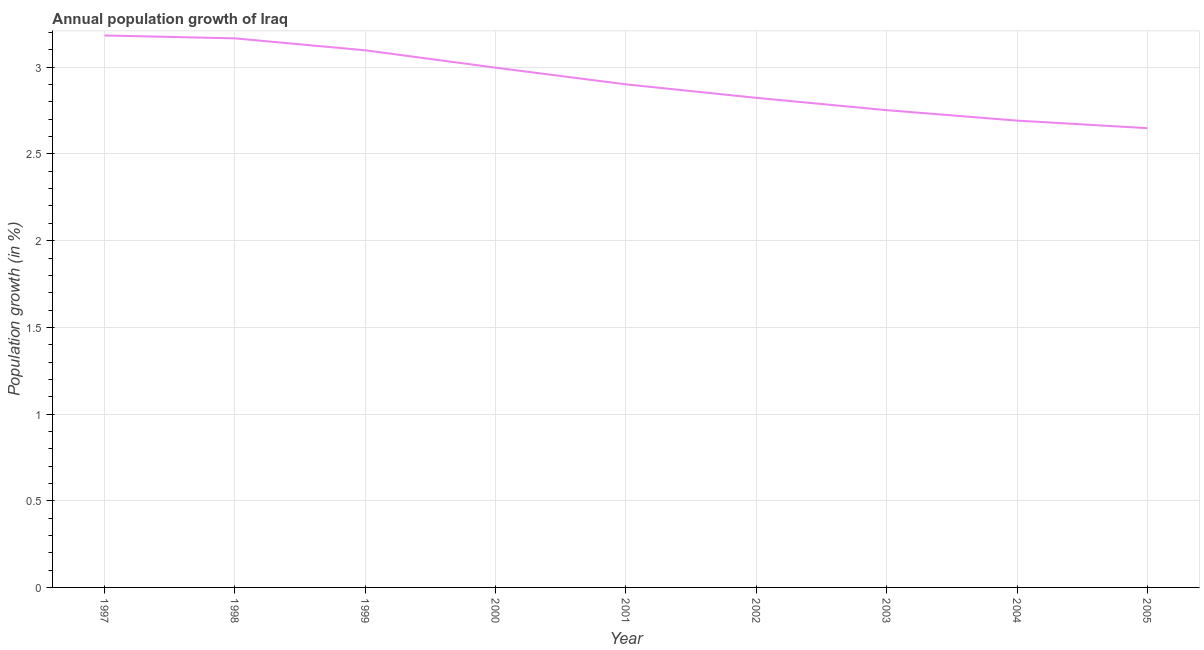What is the population growth in 2002?
Provide a short and direct response. 2.82. Across all years, what is the maximum population growth?
Make the answer very short. 3.18. Across all years, what is the minimum population growth?
Provide a succinct answer. 2.65. In which year was the population growth maximum?
Ensure brevity in your answer.  1997. In which year was the population growth minimum?
Provide a succinct answer. 2005. What is the sum of the population growth?
Offer a very short reply. 26.27. What is the difference between the population growth in 1999 and 2002?
Your answer should be compact. 0.27. What is the average population growth per year?
Give a very brief answer. 2.92. What is the median population growth?
Make the answer very short. 2.9. In how many years, is the population growth greater than 2.7 %?
Your answer should be very brief. 7. Do a majority of the years between 2004 and 2002 (inclusive) have population growth greater than 0.8 %?
Offer a terse response. No. What is the ratio of the population growth in 2000 to that in 2004?
Make the answer very short. 1.11. Is the population growth in 1997 less than that in 2002?
Make the answer very short. No. Is the difference between the population growth in 2000 and 2004 greater than the difference between any two years?
Your answer should be very brief. No. What is the difference between the highest and the second highest population growth?
Ensure brevity in your answer.  0.02. Is the sum of the population growth in 2000 and 2002 greater than the maximum population growth across all years?
Provide a short and direct response. Yes. What is the difference between the highest and the lowest population growth?
Give a very brief answer. 0.53. Does the population growth monotonically increase over the years?
Ensure brevity in your answer.  No. How many lines are there?
Offer a very short reply. 1. How many years are there in the graph?
Keep it short and to the point. 9. What is the title of the graph?
Keep it short and to the point. Annual population growth of Iraq. What is the label or title of the X-axis?
Your response must be concise. Year. What is the label or title of the Y-axis?
Your response must be concise. Population growth (in %). What is the Population growth (in %) of 1997?
Keep it short and to the point. 3.18. What is the Population growth (in %) of 1998?
Give a very brief answer. 3.17. What is the Population growth (in %) in 1999?
Your response must be concise. 3.1. What is the Population growth (in %) of 2000?
Ensure brevity in your answer.  3. What is the Population growth (in %) of 2001?
Your response must be concise. 2.9. What is the Population growth (in %) of 2002?
Provide a short and direct response. 2.82. What is the Population growth (in %) of 2003?
Offer a terse response. 2.75. What is the Population growth (in %) of 2004?
Your answer should be very brief. 2.69. What is the Population growth (in %) in 2005?
Keep it short and to the point. 2.65. What is the difference between the Population growth (in %) in 1997 and 1998?
Provide a short and direct response. 0.02. What is the difference between the Population growth (in %) in 1997 and 1999?
Give a very brief answer. 0.09. What is the difference between the Population growth (in %) in 1997 and 2000?
Provide a succinct answer. 0.19. What is the difference between the Population growth (in %) in 1997 and 2001?
Make the answer very short. 0.28. What is the difference between the Population growth (in %) in 1997 and 2002?
Your answer should be compact. 0.36. What is the difference between the Population growth (in %) in 1997 and 2003?
Your answer should be very brief. 0.43. What is the difference between the Population growth (in %) in 1997 and 2004?
Provide a succinct answer. 0.49. What is the difference between the Population growth (in %) in 1997 and 2005?
Ensure brevity in your answer.  0.53. What is the difference between the Population growth (in %) in 1998 and 1999?
Give a very brief answer. 0.07. What is the difference between the Population growth (in %) in 1998 and 2000?
Provide a succinct answer. 0.17. What is the difference between the Population growth (in %) in 1998 and 2001?
Keep it short and to the point. 0.27. What is the difference between the Population growth (in %) in 1998 and 2002?
Give a very brief answer. 0.34. What is the difference between the Population growth (in %) in 1998 and 2003?
Provide a short and direct response. 0.41. What is the difference between the Population growth (in %) in 1998 and 2004?
Give a very brief answer. 0.47. What is the difference between the Population growth (in %) in 1998 and 2005?
Give a very brief answer. 0.52. What is the difference between the Population growth (in %) in 1999 and 2000?
Ensure brevity in your answer.  0.1. What is the difference between the Population growth (in %) in 1999 and 2001?
Your answer should be very brief. 0.2. What is the difference between the Population growth (in %) in 1999 and 2002?
Your answer should be compact. 0.27. What is the difference between the Population growth (in %) in 1999 and 2003?
Offer a terse response. 0.35. What is the difference between the Population growth (in %) in 1999 and 2004?
Ensure brevity in your answer.  0.41. What is the difference between the Population growth (in %) in 1999 and 2005?
Provide a succinct answer. 0.45. What is the difference between the Population growth (in %) in 2000 and 2001?
Offer a very short reply. 0.1. What is the difference between the Population growth (in %) in 2000 and 2002?
Your answer should be very brief. 0.17. What is the difference between the Population growth (in %) in 2000 and 2003?
Your answer should be very brief. 0.25. What is the difference between the Population growth (in %) in 2000 and 2004?
Your answer should be compact. 0.31. What is the difference between the Population growth (in %) in 2000 and 2005?
Ensure brevity in your answer.  0.35. What is the difference between the Population growth (in %) in 2001 and 2002?
Give a very brief answer. 0.08. What is the difference between the Population growth (in %) in 2001 and 2003?
Provide a short and direct response. 0.15. What is the difference between the Population growth (in %) in 2001 and 2004?
Make the answer very short. 0.21. What is the difference between the Population growth (in %) in 2001 and 2005?
Provide a short and direct response. 0.25. What is the difference between the Population growth (in %) in 2002 and 2003?
Make the answer very short. 0.07. What is the difference between the Population growth (in %) in 2002 and 2004?
Provide a short and direct response. 0.13. What is the difference between the Population growth (in %) in 2002 and 2005?
Ensure brevity in your answer.  0.17. What is the difference between the Population growth (in %) in 2003 and 2004?
Your answer should be compact. 0.06. What is the difference between the Population growth (in %) in 2003 and 2005?
Offer a terse response. 0.1. What is the difference between the Population growth (in %) in 2004 and 2005?
Offer a very short reply. 0.04. What is the ratio of the Population growth (in %) in 1997 to that in 1998?
Your answer should be compact. 1. What is the ratio of the Population growth (in %) in 1997 to that in 1999?
Keep it short and to the point. 1.03. What is the ratio of the Population growth (in %) in 1997 to that in 2000?
Keep it short and to the point. 1.06. What is the ratio of the Population growth (in %) in 1997 to that in 2001?
Your answer should be very brief. 1.1. What is the ratio of the Population growth (in %) in 1997 to that in 2002?
Offer a terse response. 1.13. What is the ratio of the Population growth (in %) in 1997 to that in 2003?
Your answer should be very brief. 1.16. What is the ratio of the Population growth (in %) in 1997 to that in 2004?
Ensure brevity in your answer.  1.18. What is the ratio of the Population growth (in %) in 1997 to that in 2005?
Your answer should be very brief. 1.2. What is the ratio of the Population growth (in %) in 1998 to that in 2000?
Make the answer very short. 1.06. What is the ratio of the Population growth (in %) in 1998 to that in 2001?
Keep it short and to the point. 1.09. What is the ratio of the Population growth (in %) in 1998 to that in 2002?
Offer a terse response. 1.12. What is the ratio of the Population growth (in %) in 1998 to that in 2003?
Offer a terse response. 1.15. What is the ratio of the Population growth (in %) in 1998 to that in 2004?
Your response must be concise. 1.18. What is the ratio of the Population growth (in %) in 1998 to that in 2005?
Ensure brevity in your answer.  1.2. What is the ratio of the Population growth (in %) in 1999 to that in 2000?
Ensure brevity in your answer.  1.03. What is the ratio of the Population growth (in %) in 1999 to that in 2001?
Keep it short and to the point. 1.07. What is the ratio of the Population growth (in %) in 1999 to that in 2002?
Offer a very short reply. 1.1. What is the ratio of the Population growth (in %) in 1999 to that in 2003?
Your answer should be compact. 1.12. What is the ratio of the Population growth (in %) in 1999 to that in 2004?
Your answer should be compact. 1.15. What is the ratio of the Population growth (in %) in 1999 to that in 2005?
Your response must be concise. 1.17. What is the ratio of the Population growth (in %) in 2000 to that in 2001?
Provide a short and direct response. 1.03. What is the ratio of the Population growth (in %) in 2000 to that in 2002?
Your answer should be compact. 1.06. What is the ratio of the Population growth (in %) in 2000 to that in 2003?
Offer a very short reply. 1.09. What is the ratio of the Population growth (in %) in 2000 to that in 2004?
Keep it short and to the point. 1.11. What is the ratio of the Population growth (in %) in 2000 to that in 2005?
Provide a succinct answer. 1.13. What is the ratio of the Population growth (in %) in 2001 to that in 2002?
Provide a short and direct response. 1.03. What is the ratio of the Population growth (in %) in 2001 to that in 2003?
Ensure brevity in your answer.  1.05. What is the ratio of the Population growth (in %) in 2001 to that in 2004?
Provide a short and direct response. 1.08. What is the ratio of the Population growth (in %) in 2001 to that in 2005?
Offer a terse response. 1.09. What is the ratio of the Population growth (in %) in 2002 to that in 2004?
Ensure brevity in your answer.  1.05. What is the ratio of the Population growth (in %) in 2002 to that in 2005?
Ensure brevity in your answer.  1.07. What is the ratio of the Population growth (in %) in 2003 to that in 2004?
Offer a terse response. 1.02. What is the ratio of the Population growth (in %) in 2003 to that in 2005?
Your answer should be very brief. 1.04. What is the ratio of the Population growth (in %) in 2004 to that in 2005?
Your response must be concise. 1.02. 